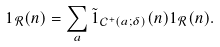Convert formula to latex. <formula><loc_0><loc_0><loc_500><loc_500>1 _ { \mathcal { R } } ( n ) = \sum _ { a } \tilde { 1 } _ { \mathcal { C } ^ { + } ( a ; \delta ) } ( n ) 1 _ { \mathcal { R } } ( n ) .</formula> 